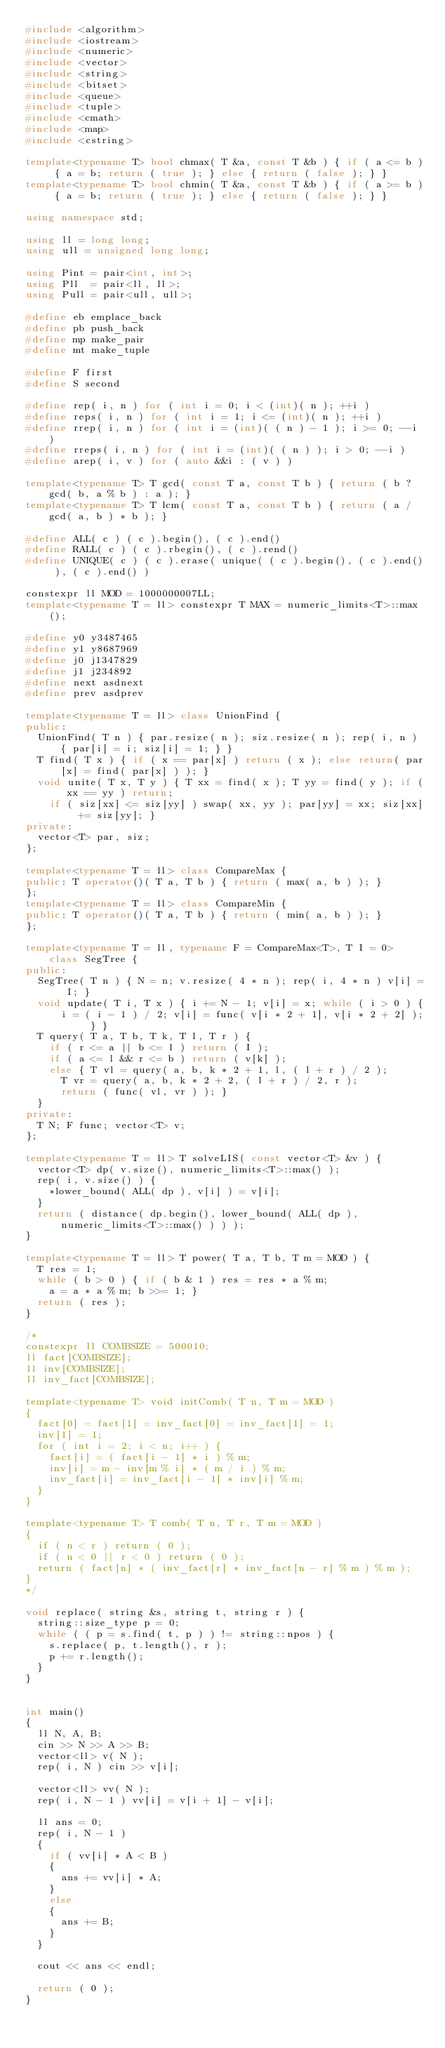Convert code to text. <code><loc_0><loc_0><loc_500><loc_500><_C++_>#include <algorithm>
#include <iostream>
#include <numeric>
#include <vector>
#include <string>
#include <bitset>
#include <queue>
#include <tuple>
#include <cmath>
#include <map>
#include <cstring>

template<typename T> bool chmax( T &a, const T &b ) { if ( a <= b ) { a = b; return ( true ); } else { return ( false ); } }
template<typename T> bool chmin( T &a, const T &b ) { if ( a >= b ) { a = b; return ( true ); } else { return ( false ); } }

using namespace std;

using ll = long long;
using ull = unsigned long long;

using Pint = pair<int, int>;
using Pll  = pair<ll, ll>;
using Pull = pair<ull, ull>;

#define eb emplace_back
#define pb push_back
#define mp make_pair
#define mt make_tuple

#define F first
#define S second

#define rep( i, n ) for ( int i = 0; i < (int)( n ); ++i )
#define reps( i, n ) for ( int i = 1; i <= (int)( n ); ++i )
#define rrep( i, n ) for ( int i = (int)( ( n ) - 1 ); i >= 0; --i )
#define rreps( i, n ) for ( int i = (int)( ( n ) ); i > 0; --i )
#define arep( i, v ) for ( auto &&i : ( v ) )

template<typename T> T gcd( const T a, const T b ) { return ( b ? gcd( b, a % b ) : a ); }
template<typename T> T lcm( const T a, const T b ) { return ( a / gcd( a, b ) * b ); }

#define ALL( c ) ( c ).begin(), ( c ).end()
#define RALL( c ) ( c ).rbegin(), ( c ).rend()
#define UNIQUE( c ) ( c ).erase( unique( ( c ).begin(), ( c ).end() ), ( c ).end() )

constexpr ll MOD = 1000000007LL;
template<typename T = ll> constexpr T MAX = numeric_limits<T>::max();

#define y0 y3487465
#define y1 y8687969
#define j0 j1347829
#define j1 j234892
#define next asdnext
#define prev asdprev

template<typename T = ll> class UnionFind {
public:
	UnionFind( T n ) { par.resize( n ); siz.resize( n ); rep( i, n ) { par[i] = i; siz[i] = 1; } }
	T find( T x ) { if ( x == par[x] ) return ( x ); else return( par[x] = find( par[x] ) ); }
	void unite( T x, T y ) { T xx = find( x ); T yy = find( y ); if ( xx == yy ) return;
		if ( siz[xx] <= siz[yy] ) swap( xx, yy ); par[yy] = xx; siz[xx] += siz[yy]; }
private:
	vector<T> par, siz;
};

template<typename T = ll> class CompareMax {
public:	T operator()( T a, T b ) { return ( max( a, b ) ); }
};
template<typename T = ll> class CompareMin {
public:	T operator()( T a, T b ) { return ( min( a, b ) ); }
};

template<typename T = ll, typename F = CompareMax<T>, T I = 0> class SegTree {
public:
	SegTree( T n ) { N = n; v.resize( 4 * n ); rep( i, 4 * n ) v[i] = I; }
	void update( T i, T x ) { i += N - 1; v[i] = x; while ( i > 0 ) {
			i = ( i - 1 ) / 2; v[i] = func( v[i * 2 + 1], v[i * 2 + 2] ); } }
	T query( T a, T b, T k, T l, T r ) {
		if ( r <= a || b <= l ) return ( I );
		if ( a <= l && r <= b ) return ( v[k] );
		else { T vl = query( a, b, k * 2 + 1, l, ( l + r ) / 2 );
			T vr = query( a, b, k * 2 + 2, ( l + r ) / 2, r );
			return ( func( vl, vr ) ); }
	}
private:
	T N; F func; vector<T> v;
};

template<typename T = ll> T solveLIS( const vector<T> &v ) {
	vector<T> dp( v.size(), numeric_limits<T>::max() );
	rep( i, v.size() ) {
		*lower_bound( ALL( dp ), v[i] ) = v[i];
	}
	return ( distance( dp.begin(), lower_bound( ALL( dp ), numeric_limits<T>::max() ) ) );
}

template<typename T = ll> T power( T a, T b, T m = MOD ) {
	T res = 1;
	while ( b > 0 ) { if ( b & 1 ) res = res * a % m;
		a = a * a % m; b >>= 1; }
	return ( res );
}

/*
constexpr ll COMBSIZE = 500010;
ll fact[COMBSIZE];
ll inv[COMBSIZE];
ll inv_fact[COMBSIZE];

template<typename T> void initComb( T n, T m = MOD )
{
	fact[0] = fact[1] = inv_fact[0] = inv_fact[1] = 1;
	inv[1] = 1;
	for ( int i = 2; i < n; i++ ) {
		fact[i] = ( fact[i - 1] * i ) % m;
		inv[i] = m - inv[m % i] * ( m / i ) % m;
		inv_fact[i] = inv_fact[i - 1] * inv[i] % m;
	}
}

template<typename T> T comb( T n, T r, T m = MOD )
{
	if ( n < r ) return ( 0 );
	if ( n < 0 || r < 0 ) return ( 0 );
	return ( fact[n] * ( inv_fact[r] * inv_fact[n - r] % m ) % m );
}
*/

void replace( string &s, string t, string r ) {
	string::size_type p = 0;
	while ( ( p = s.find( t, p ) ) != string::npos ) {
		s.replace( p, t.length(), r );
		p += r.length();
	}
}


int main()
{
	ll N, A, B;
	cin >> N >> A >> B;
	vector<ll> v( N );
	rep( i, N ) cin >> v[i];

	vector<ll> vv( N );
	rep( i, N - 1 ) vv[i] = v[i + 1] - v[i];

	ll ans = 0;
	rep( i, N - 1 )
	{
		if ( vv[i] * A < B )
		{
			ans += vv[i] * A;
		}
		else
		{
			ans += B;
		}
	}

	cout << ans << endl;

	return ( 0 );
}
</code> 